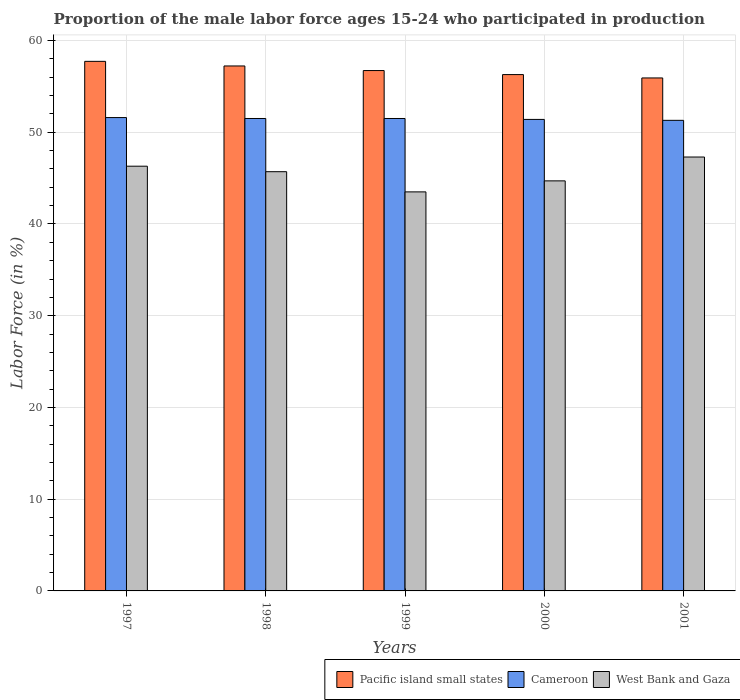How many different coloured bars are there?
Offer a terse response. 3. How many groups of bars are there?
Ensure brevity in your answer.  5. What is the label of the 5th group of bars from the left?
Your answer should be compact. 2001. In how many cases, is the number of bars for a given year not equal to the number of legend labels?
Provide a succinct answer. 0. What is the proportion of the male labor force who participated in production in West Bank and Gaza in 2000?
Ensure brevity in your answer.  44.7. Across all years, what is the maximum proportion of the male labor force who participated in production in West Bank and Gaza?
Your answer should be very brief. 47.3. Across all years, what is the minimum proportion of the male labor force who participated in production in Cameroon?
Keep it short and to the point. 51.3. What is the total proportion of the male labor force who participated in production in Cameroon in the graph?
Make the answer very short. 257.3. What is the difference between the proportion of the male labor force who participated in production in West Bank and Gaza in 1999 and that in 2001?
Provide a short and direct response. -3.8. What is the difference between the proportion of the male labor force who participated in production in Cameroon in 1997 and the proportion of the male labor force who participated in production in West Bank and Gaza in 1999?
Make the answer very short. 8.1. What is the average proportion of the male labor force who participated in production in Pacific island small states per year?
Your response must be concise. 56.78. In the year 1999, what is the difference between the proportion of the male labor force who participated in production in Cameroon and proportion of the male labor force who participated in production in Pacific island small states?
Make the answer very short. -5.23. In how many years, is the proportion of the male labor force who participated in production in Cameroon greater than 34 %?
Your answer should be very brief. 5. What is the ratio of the proportion of the male labor force who participated in production in Pacific island small states in 1997 to that in 1998?
Your response must be concise. 1.01. Is the difference between the proportion of the male labor force who participated in production in Cameroon in 1998 and 1999 greater than the difference between the proportion of the male labor force who participated in production in Pacific island small states in 1998 and 1999?
Your answer should be compact. No. What is the difference between the highest and the second highest proportion of the male labor force who participated in production in Pacific island small states?
Keep it short and to the point. 0.5. What is the difference between the highest and the lowest proportion of the male labor force who participated in production in Cameroon?
Provide a succinct answer. 0.3. Is the sum of the proportion of the male labor force who participated in production in Cameroon in 1999 and 2001 greater than the maximum proportion of the male labor force who participated in production in West Bank and Gaza across all years?
Your answer should be very brief. Yes. What does the 3rd bar from the left in 1997 represents?
Give a very brief answer. West Bank and Gaza. What does the 1st bar from the right in 1999 represents?
Make the answer very short. West Bank and Gaza. Is it the case that in every year, the sum of the proportion of the male labor force who participated in production in Pacific island small states and proportion of the male labor force who participated in production in Cameroon is greater than the proportion of the male labor force who participated in production in West Bank and Gaza?
Your answer should be compact. Yes. Are all the bars in the graph horizontal?
Offer a terse response. No. How many years are there in the graph?
Ensure brevity in your answer.  5. Does the graph contain any zero values?
Offer a terse response. No. Where does the legend appear in the graph?
Your answer should be very brief. Bottom right. How many legend labels are there?
Ensure brevity in your answer.  3. What is the title of the graph?
Make the answer very short. Proportion of the male labor force ages 15-24 who participated in production. Does "Australia" appear as one of the legend labels in the graph?
Your answer should be compact. No. What is the Labor Force (in %) of Pacific island small states in 1997?
Make the answer very short. 57.73. What is the Labor Force (in %) of Cameroon in 1997?
Make the answer very short. 51.6. What is the Labor Force (in %) in West Bank and Gaza in 1997?
Provide a succinct answer. 46.3. What is the Labor Force (in %) in Pacific island small states in 1998?
Your response must be concise. 57.23. What is the Labor Force (in %) of Cameroon in 1998?
Provide a succinct answer. 51.5. What is the Labor Force (in %) of West Bank and Gaza in 1998?
Offer a very short reply. 45.7. What is the Labor Force (in %) of Pacific island small states in 1999?
Your answer should be compact. 56.73. What is the Labor Force (in %) of Cameroon in 1999?
Offer a very short reply. 51.5. What is the Labor Force (in %) of West Bank and Gaza in 1999?
Your answer should be compact. 43.5. What is the Labor Force (in %) of Pacific island small states in 2000?
Make the answer very short. 56.29. What is the Labor Force (in %) of Cameroon in 2000?
Your answer should be compact. 51.4. What is the Labor Force (in %) in West Bank and Gaza in 2000?
Offer a very short reply. 44.7. What is the Labor Force (in %) in Pacific island small states in 2001?
Keep it short and to the point. 55.92. What is the Labor Force (in %) in Cameroon in 2001?
Your answer should be very brief. 51.3. What is the Labor Force (in %) in West Bank and Gaza in 2001?
Your response must be concise. 47.3. Across all years, what is the maximum Labor Force (in %) in Pacific island small states?
Keep it short and to the point. 57.73. Across all years, what is the maximum Labor Force (in %) in Cameroon?
Your response must be concise. 51.6. Across all years, what is the maximum Labor Force (in %) in West Bank and Gaza?
Offer a very short reply. 47.3. Across all years, what is the minimum Labor Force (in %) of Pacific island small states?
Your response must be concise. 55.92. Across all years, what is the minimum Labor Force (in %) in Cameroon?
Make the answer very short. 51.3. Across all years, what is the minimum Labor Force (in %) in West Bank and Gaza?
Offer a terse response. 43.5. What is the total Labor Force (in %) in Pacific island small states in the graph?
Your response must be concise. 283.89. What is the total Labor Force (in %) in Cameroon in the graph?
Keep it short and to the point. 257.3. What is the total Labor Force (in %) in West Bank and Gaza in the graph?
Give a very brief answer. 227.5. What is the difference between the Labor Force (in %) of Pacific island small states in 1997 and that in 1998?
Offer a very short reply. 0.5. What is the difference between the Labor Force (in %) in Cameroon in 1997 and that in 1998?
Give a very brief answer. 0.1. What is the difference between the Labor Force (in %) in West Bank and Gaza in 1997 and that in 1998?
Give a very brief answer. 0.6. What is the difference between the Labor Force (in %) of Pacific island small states in 1997 and that in 1999?
Offer a terse response. 1. What is the difference between the Labor Force (in %) of Pacific island small states in 1997 and that in 2000?
Your answer should be compact. 1.44. What is the difference between the Labor Force (in %) in Cameroon in 1997 and that in 2000?
Your response must be concise. 0.2. What is the difference between the Labor Force (in %) in Pacific island small states in 1997 and that in 2001?
Give a very brief answer. 1.81. What is the difference between the Labor Force (in %) in Cameroon in 1997 and that in 2001?
Your answer should be very brief. 0.3. What is the difference between the Labor Force (in %) in Pacific island small states in 1998 and that in 1999?
Your answer should be compact. 0.5. What is the difference between the Labor Force (in %) in Pacific island small states in 1998 and that in 2000?
Your answer should be very brief. 0.94. What is the difference between the Labor Force (in %) in West Bank and Gaza in 1998 and that in 2000?
Your answer should be compact. 1. What is the difference between the Labor Force (in %) of Pacific island small states in 1998 and that in 2001?
Ensure brevity in your answer.  1.31. What is the difference between the Labor Force (in %) in Cameroon in 1998 and that in 2001?
Ensure brevity in your answer.  0.2. What is the difference between the Labor Force (in %) in West Bank and Gaza in 1998 and that in 2001?
Give a very brief answer. -1.6. What is the difference between the Labor Force (in %) of Pacific island small states in 1999 and that in 2000?
Keep it short and to the point. 0.44. What is the difference between the Labor Force (in %) of Pacific island small states in 1999 and that in 2001?
Your answer should be compact. 0.81. What is the difference between the Labor Force (in %) of Cameroon in 1999 and that in 2001?
Your answer should be very brief. 0.2. What is the difference between the Labor Force (in %) of Pacific island small states in 2000 and that in 2001?
Your response must be concise. 0.37. What is the difference between the Labor Force (in %) in West Bank and Gaza in 2000 and that in 2001?
Make the answer very short. -2.6. What is the difference between the Labor Force (in %) in Pacific island small states in 1997 and the Labor Force (in %) in Cameroon in 1998?
Offer a terse response. 6.23. What is the difference between the Labor Force (in %) of Pacific island small states in 1997 and the Labor Force (in %) of West Bank and Gaza in 1998?
Give a very brief answer. 12.03. What is the difference between the Labor Force (in %) in Cameroon in 1997 and the Labor Force (in %) in West Bank and Gaza in 1998?
Provide a short and direct response. 5.9. What is the difference between the Labor Force (in %) in Pacific island small states in 1997 and the Labor Force (in %) in Cameroon in 1999?
Your answer should be compact. 6.23. What is the difference between the Labor Force (in %) in Pacific island small states in 1997 and the Labor Force (in %) in West Bank and Gaza in 1999?
Your response must be concise. 14.23. What is the difference between the Labor Force (in %) of Pacific island small states in 1997 and the Labor Force (in %) of Cameroon in 2000?
Provide a succinct answer. 6.33. What is the difference between the Labor Force (in %) in Pacific island small states in 1997 and the Labor Force (in %) in West Bank and Gaza in 2000?
Offer a terse response. 13.03. What is the difference between the Labor Force (in %) of Pacific island small states in 1997 and the Labor Force (in %) of Cameroon in 2001?
Your answer should be compact. 6.43. What is the difference between the Labor Force (in %) in Pacific island small states in 1997 and the Labor Force (in %) in West Bank and Gaza in 2001?
Your answer should be very brief. 10.43. What is the difference between the Labor Force (in %) in Cameroon in 1997 and the Labor Force (in %) in West Bank and Gaza in 2001?
Give a very brief answer. 4.3. What is the difference between the Labor Force (in %) in Pacific island small states in 1998 and the Labor Force (in %) in Cameroon in 1999?
Offer a very short reply. 5.73. What is the difference between the Labor Force (in %) in Pacific island small states in 1998 and the Labor Force (in %) in West Bank and Gaza in 1999?
Ensure brevity in your answer.  13.73. What is the difference between the Labor Force (in %) in Cameroon in 1998 and the Labor Force (in %) in West Bank and Gaza in 1999?
Offer a very short reply. 8. What is the difference between the Labor Force (in %) of Pacific island small states in 1998 and the Labor Force (in %) of Cameroon in 2000?
Your response must be concise. 5.83. What is the difference between the Labor Force (in %) in Pacific island small states in 1998 and the Labor Force (in %) in West Bank and Gaza in 2000?
Your answer should be compact. 12.53. What is the difference between the Labor Force (in %) in Pacific island small states in 1998 and the Labor Force (in %) in Cameroon in 2001?
Offer a very short reply. 5.93. What is the difference between the Labor Force (in %) in Pacific island small states in 1998 and the Labor Force (in %) in West Bank and Gaza in 2001?
Offer a very short reply. 9.93. What is the difference between the Labor Force (in %) in Cameroon in 1998 and the Labor Force (in %) in West Bank and Gaza in 2001?
Give a very brief answer. 4.2. What is the difference between the Labor Force (in %) of Pacific island small states in 1999 and the Labor Force (in %) of Cameroon in 2000?
Your answer should be very brief. 5.33. What is the difference between the Labor Force (in %) of Pacific island small states in 1999 and the Labor Force (in %) of West Bank and Gaza in 2000?
Your answer should be compact. 12.03. What is the difference between the Labor Force (in %) in Pacific island small states in 1999 and the Labor Force (in %) in Cameroon in 2001?
Your answer should be compact. 5.43. What is the difference between the Labor Force (in %) in Pacific island small states in 1999 and the Labor Force (in %) in West Bank and Gaza in 2001?
Your answer should be compact. 9.43. What is the difference between the Labor Force (in %) of Cameroon in 1999 and the Labor Force (in %) of West Bank and Gaza in 2001?
Provide a short and direct response. 4.2. What is the difference between the Labor Force (in %) in Pacific island small states in 2000 and the Labor Force (in %) in Cameroon in 2001?
Your answer should be very brief. 4.99. What is the difference between the Labor Force (in %) in Pacific island small states in 2000 and the Labor Force (in %) in West Bank and Gaza in 2001?
Your response must be concise. 8.99. What is the difference between the Labor Force (in %) of Cameroon in 2000 and the Labor Force (in %) of West Bank and Gaza in 2001?
Provide a short and direct response. 4.1. What is the average Labor Force (in %) in Pacific island small states per year?
Offer a very short reply. 56.78. What is the average Labor Force (in %) of Cameroon per year?
Your response must be concise. 51.46. What is the average Labor Force (in %) of West Bank and Gaza per year?
Make the answer very short. 45.5. In the year 1997, what is the difference between the Labor Force (in %) in Pacific island small states and Labor Force (in %) in Cameroon?
Your answer should be compact. 6.13. In the year 1997, what is the difference between the Labor Force (in %) in Pacific island small states and Labor Force (in %) in West Bank and Gaza?
Ensure brevity in your answer.  11.43. In the year 1997, what is the difference between the Labor Force (in %) in Cameroon and Labor Force (in %) in West Bank and Gaza?
Your answer should be compact. 5.3. In the year 1998, what is the difference between the Labor Force (in %) of Pacific island small states and Labor Force (in %) of Cameroon?
Provide a succinct answer. 5.73. In the year 1998, what is the difference between the Labor Force (in %) of Pacific island small states and Labor Force (in %) of West Bank and Gaza?
Your response must be concise. 11.53. In the year 1998, what is the difference between the Labor Force (in %) in Cameroon and Labor Force (in %) in West Bank and Gaza?
Your answer should be very brief. 5.8. In the year 1999, what is the difference between the Labor Force (in %) in Pacific island small states and Labor Force (in %) in Cameroon?
Offer a terse response. 5.23. In the year 1999, what is the difference between the Labor Force (in %) in Pacific island small states and Labor Force (in %) in West Bank and Gaza?
Provide a short and direct response. 13.23. In the year 2000, what is the difference between the Labor Force (in %) in Pacific island small states and Labor Force (in %) in Cameroon?
Ensure brevity in your answer.  4.89. In the year 2000, what is the difference between the Labor Force (in %) of Pacific island small states and Labor Force (in %) of West Bank and Gaza?
Your answer should be very brief. 11.59. In the year 2000, what is the difference between the Labor Force (in %) in Cameroon and Labor Force (in %) in West Bank and Gaza?
Ensure brevity in your answer.  6.7. In the year 2001, what is the difference between the Labor Force (in %) in Pacific island small states and Labor Force (in %) in Cameroon?
Give a very brief answer. 4.62. In the year 2001, what is the difference between the Labor Force (in %) in Pacific island small states and Labor Force (in %) in West Bank and Gaza?
Ensure brevity in your answer.  8.62. In the year 2001, what is the difference between the Labor Force (in %) in Cameroon and Labor Force (in %) in West Bank and Gaza?
Make the answer very short. 4. What is the ratio of the Labor Force (in %) of Pacific island small states in 1997 to that in 1998?
Your answer should be compact. 1.01. What is the ratio of the Labor Force (in %) in West Bank and Gaza in 1997 to that in 1998?
Provide a succinct answer. 1.01. What is the ratio of the Labor Force (in %) in Pacific island small states in 1997 to that in 1999?
Provide a short and direct response. 1.02. What is the ratio of the Labor Force (in %) in West Bank and Gaza in 1997 to that in 1999?
Your response must be concise. 1.06. What is the ratio of the Labor Force (in %) of Pacific island small states in 1997 to that in 2000?
Ensure brevity in your answer.  1.03. What is the ratio of the Labor Force (in %) of West Bank and Gaza in 1997 to that in 2000?
Your answer should be compact. 1.04. What is the ratio of the Labor Force (in %) of Pacific island small states in 1997 to that in 2001?
Offer a terse response. 1.03. What is the ratio of the Labor Force (in %) in West Bank and Gaza in 1997 to that in 2001?
Provide a short and direct response. 0.98. What is the ratio of the Labor Force (in %) in Pacific island small states in 1998 to that in 1999?
Provide a succinct answer. 1.01. What is the ratio of the Labor Force (in %) of Cameroon in 1998 to that in 1999?
Offer a terse response. 1. What is the ratio of the Labor Force (in %) of West Bank and Gaza in 1998 to that in 1999?
Give a very brief answer. 1.05. What is the ratio of the Labor Force (in %) in Pacific island small states in 1998 to that in 2000?
Your answer should be very brief. 1.02. What is the ratio of the Labor Force (in %) of Cameroon in 1998 to that in 2000?
Offer a terse response. 1. What is the ratio of the Labor Force (in %) in West Bank and Gaza in 1998 to that in 2000?
Keep it short and to the point. 1.02. What is the ratio of the Labor Force (in %) in Pacific island small states in 1998 to that in 2001?
Offer a very short reply. 1.02. What is the ratio of the Labor Force (in %) in Cameroon in 1998 to that in 2001?
Your response must be concise. 1. What is the ratio of the Labor Force (in %) in West Bank and Gaza in 1998 to that in 2001?
Provide a short and direct response. 0.97. What is the ratio of the Labor Force (in %) in West Bank and Gaza in 1999 to that in 2000?
Provide a short and direct response. 0.97. What is the ratio of the Labor Force (in %) of Pacific island small states in 1999 to that in 2001?
Provide a short and direct response. 1.01. What is the ratio of the Labor Force (in %) of West Bank and Gaza in 1999 to that in 2001?
Provide a short and direct response. 0.92. What is the ratio of the Labor Force (in %) in Pacific island small states in 2000 to that in 2001?
Make the answer very short. 1.01. What is the ratio of the Labor Force (in %) of West Bank and Gaza in 2000 to that in 2001?
Provide a short and direct response. 0.94. What is the difference between the highest and the second highest Labor Force (in %) of Pacific island small states?
Offer a terse response. 0.5. What is the difference between the highest and the second highest Labor Force (in %) of West Bank and Gaza?
Your answer should be compact. 1. What is the difference between the highest and the lowest Labor Force (in %) of Pacific island small states?
Ensure brevity in your answer.  1.81. What is the difference between the highest and the lowest Labor Force (in %) of Cameroon?
Keep it short and to the point. 0.3. What is the difference between the highest and the lowest Labor Force (in %) in West Bank and Gaza?
Offer a very short reply. 3.8. 